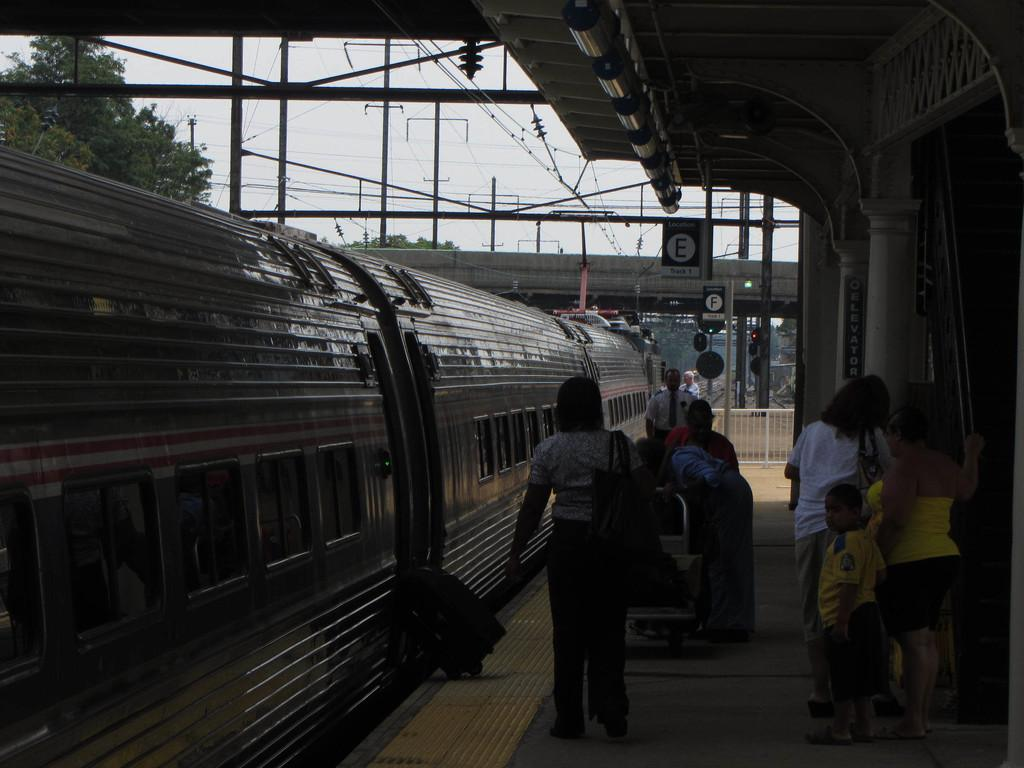Where was the image taken? The image was taken at a railway station. What can be seen in the image besides the railway station? There is a train in the image. Are there any people present in the image? Yes, there are people standing at the station. What else can be seen in the background of the image? There are electric poles and a tree in the image. What invention is being showcased on the stage in the image? There is no stage or invention present in the image; it is a scene at a railway station with a train and people. 